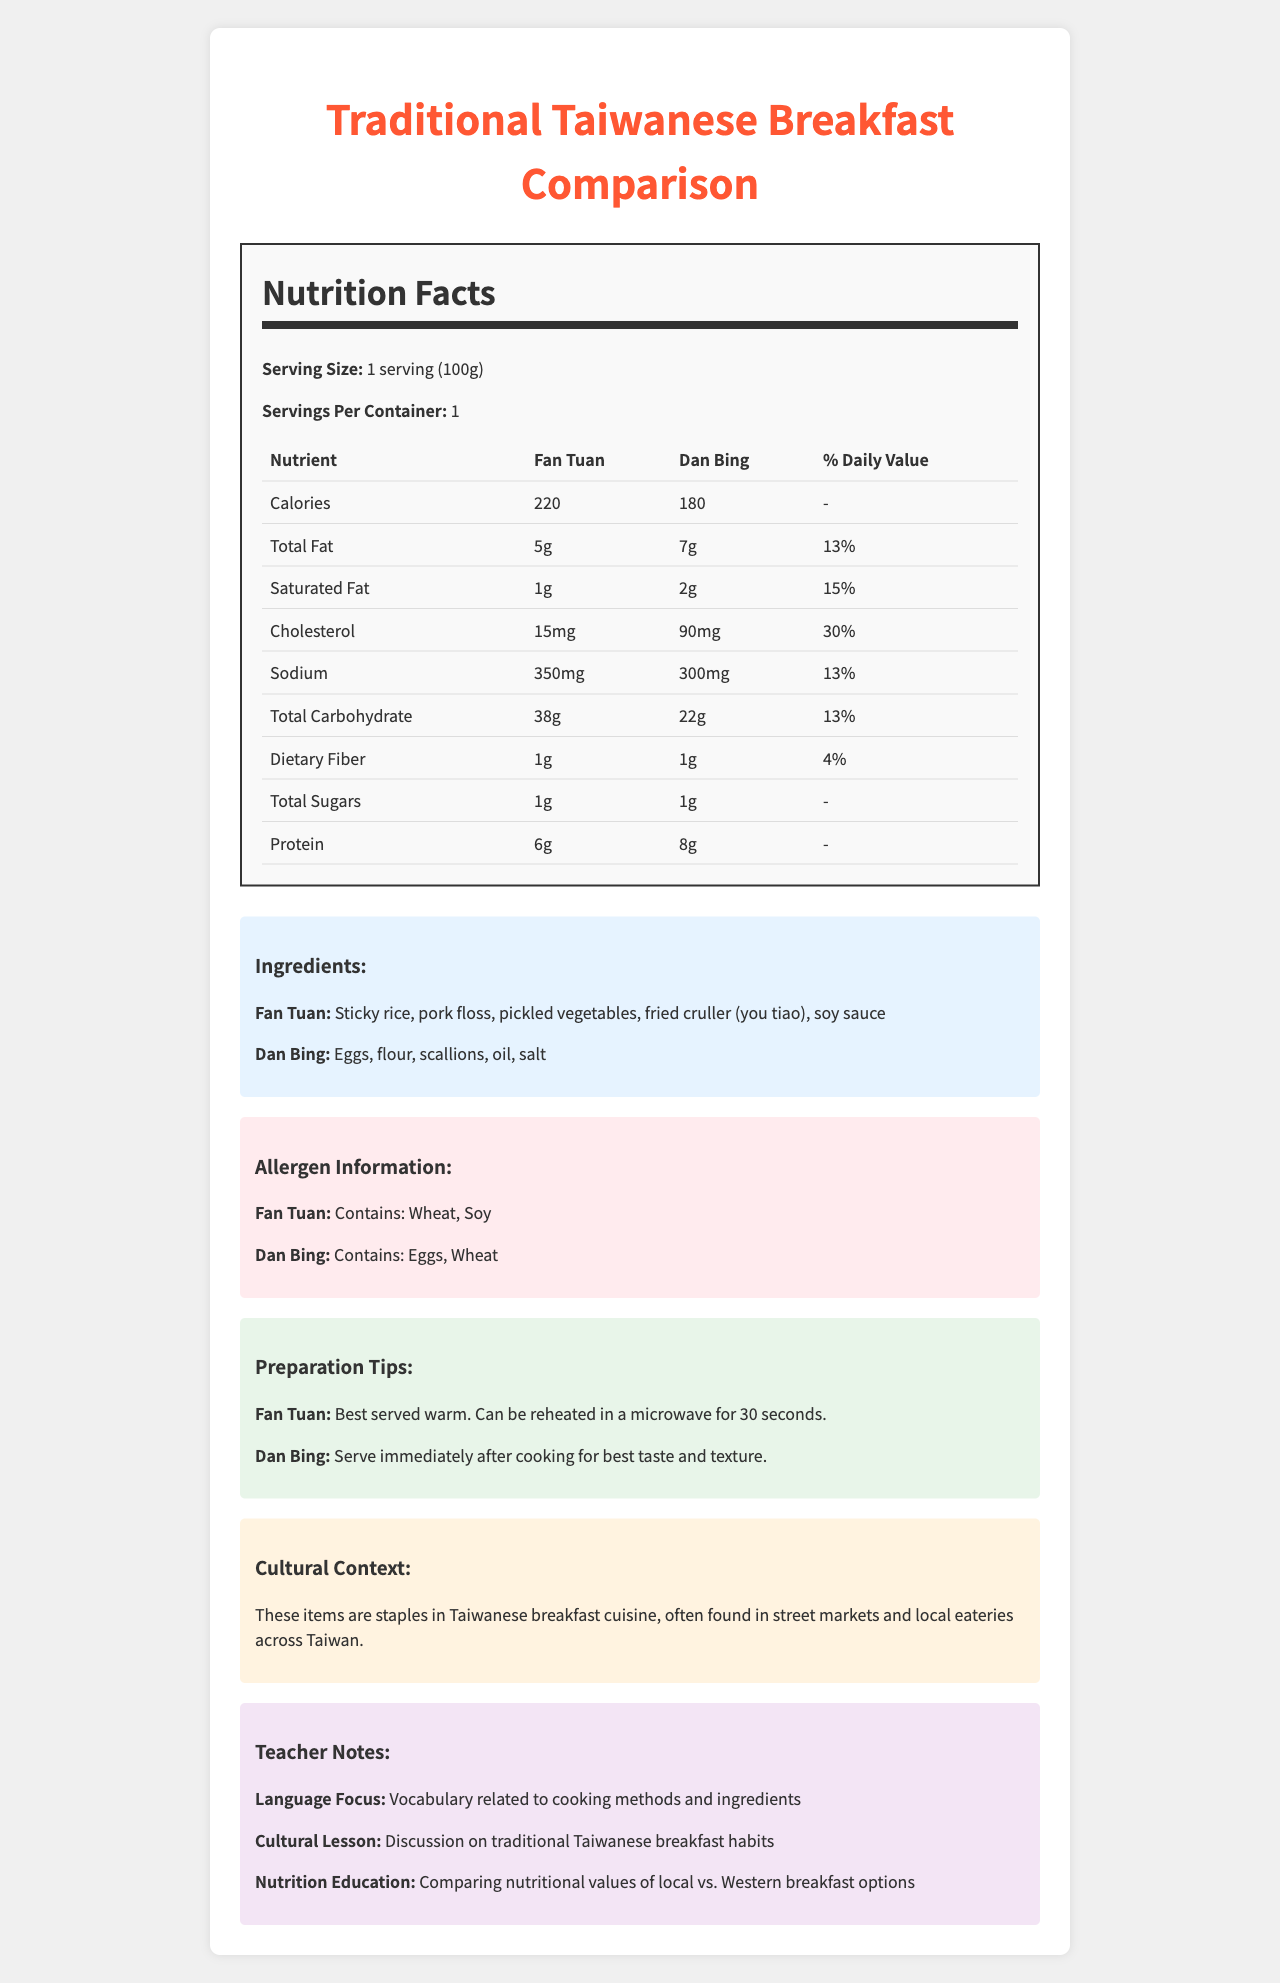What is the serving size for the items compared? The document explicitly states that the serving size is "1 serving (100g)".
Answer: 1 serving (100g) How many calories are in Fan Tuan? According to the document, Fan Tuan contains 220 calories per serving.
Answer: 220 What is the ingredient list for Dan Bing? The document lists the ingredients for Dan Bing as "Eggs, flour, scallions, oil, salt".
Answer: Eggs, flour, scallions, oil, salt Does Dan Bing contain more protein than Fan Tuan? Dan Bing contains 8g of protein, while Fan Tuan contains 6g of protein.
Answer: Yes What allergens are present in Fan Tuan? The document mentions that Fan Tuan contains wheat and soy.
Answer: Wheat, Soy Describe the main idea of the document. The document is structured to help the reader compare these two traditional Taiwanese breakfast items in terms of nutrition, ingredients, and other relevant information.
Answer: The document provides a detailed comparison of the nutrition facts, ingredients, allergen information, preparation tips, and cultural context of two traditional Taiwanese breakfast items: Fan Tuan and Dan Bing. Which item has a higher sodium content? A. Fan Tuan B. Dan Bing Fan Tuan contains 350mg of sodium, while Dan Bing contains 300mg.
Answer: A Which item is higher in saturated fat? Ⅰ. Fan Tuan Ⅱ. Dan Bing Ⅲ. They are equal Dan Bing has 2g of saturated fat compared to Fan Tuan's 1g.
Answer: Ⅱ. Dan Bing Is Fan Tuan a good source of protein? Fan Tuan contains only 6g of protein, which is relatively low compared to other protein-rich foods.
Answer: No What is the dietary fiber content of Dan Bing? The document lists the dietary fiber content for Dan Bing as 1g.
Answer: 1g Is it true that Fan Tuan has more total carbohydrates than Dan Bing? Fan Tuan has 38g of total carbohydrates, whereas Dan Bing has 22g.
Answer: Yes What percentage of daily value for cholesterol does Dan Bing provide? Dan Bing has 90mg of cholesterol, which equals 30% of the daily value for cholesterol as stated in the document.
Answer: 30% Which breakfast item is best served immediately after cooking for best taste and texture? The preparation tips section suggests that Dan Bing should be served immediately after cooking for best taste and texture.
Answer: Dan Bing What is the cultural significance of Fan Tuan and Dan Bing according to the document? The document explicitly states this cultural context in a dedicated section.
Answer: These items are staples in Taiwanese breakfast cuisine, often found in street markets and local eateries across Taiwan. How many grams of sugar are in Fan Tuan? The document lists the total sugars for Fan Tuan as 1g.
Answer: 1g What is the iron content in both breakfast items? Both Fan Tuan and Dan Bing contain 1mg of iron according to the nutrition facts table.
Answer: 1mg each How many vitamin D units are found in Fan Tuan? The document shows that Fan Tuan contains 0 units of vitamin D.
Answer: 0 Who created the recipes for these breakfast items? The document does not provide any information about who created the recipes for Fan Tuan and Dan Bing.
Answer: Not enough information 